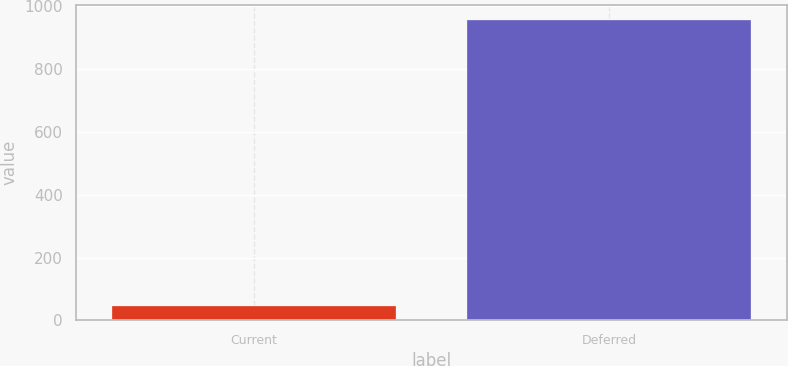Convert chart. <chart><loc_0><loc_0><loc_500><loc_500><bar_chart><fcel>Current<fcel>Deferred<nl><fcel>47<fcel>956<nl></chart> 